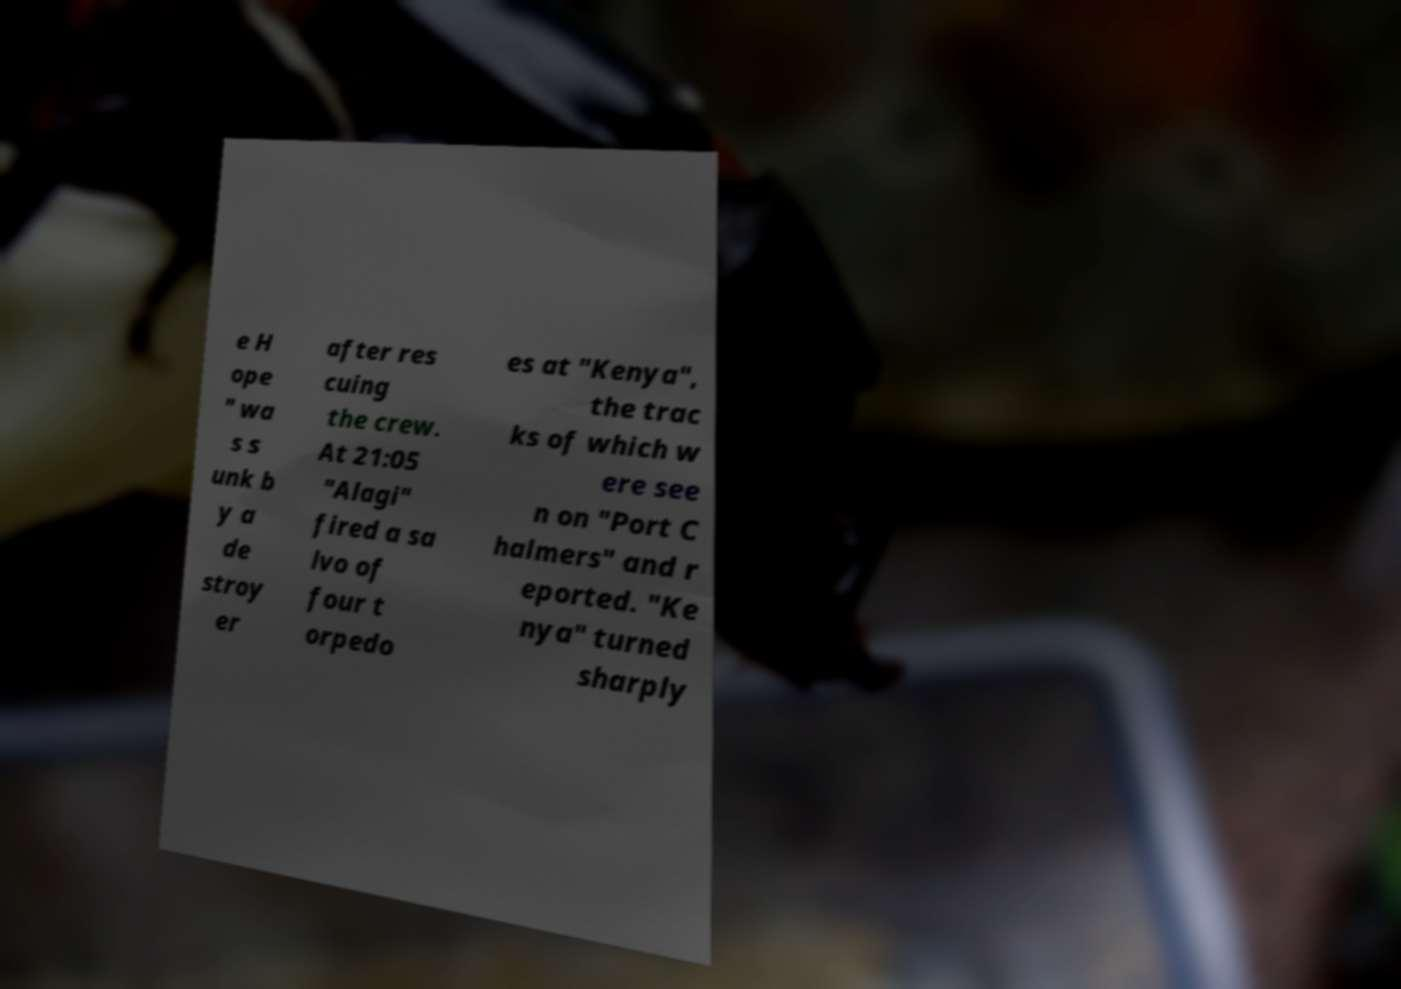What messages or text are displayed in this image? I need them in a readable, typed format. e H ope " wa s s unk b y a de stroy er after res cuing the crew. At 21:05 "Alagi" fired a sa lvo of four t orpedo es at "Kenya", the trac ks of which w ere see n on "Port C halmers" and r eported. "Ke nya" turned sharply 